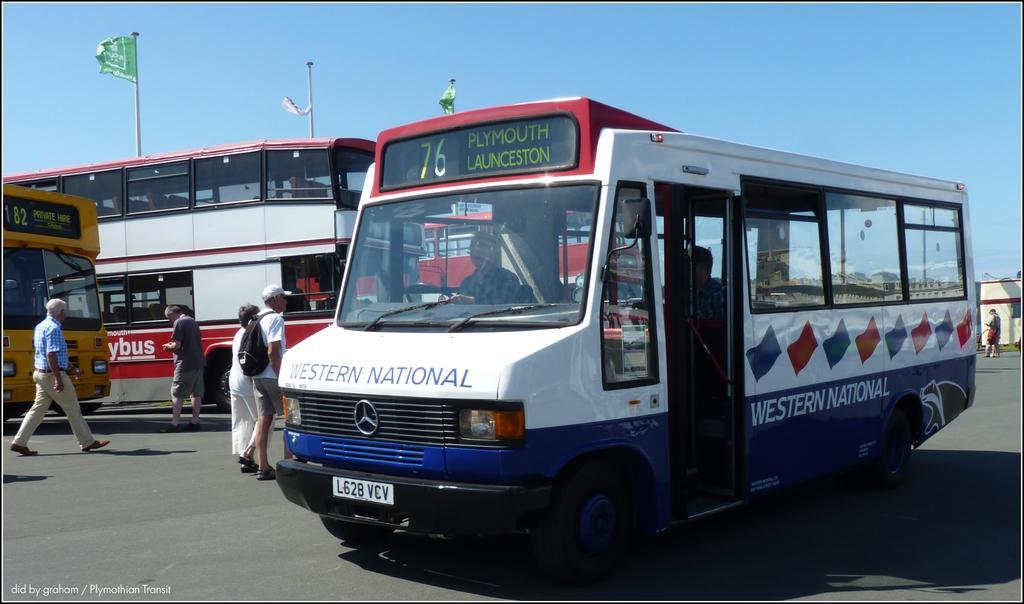How would you summarize this image in a sentence or two? In this image we can see some buses on the road. We can also see some people walking. On the backside we can see a building, some flags to the poles and the sky. 